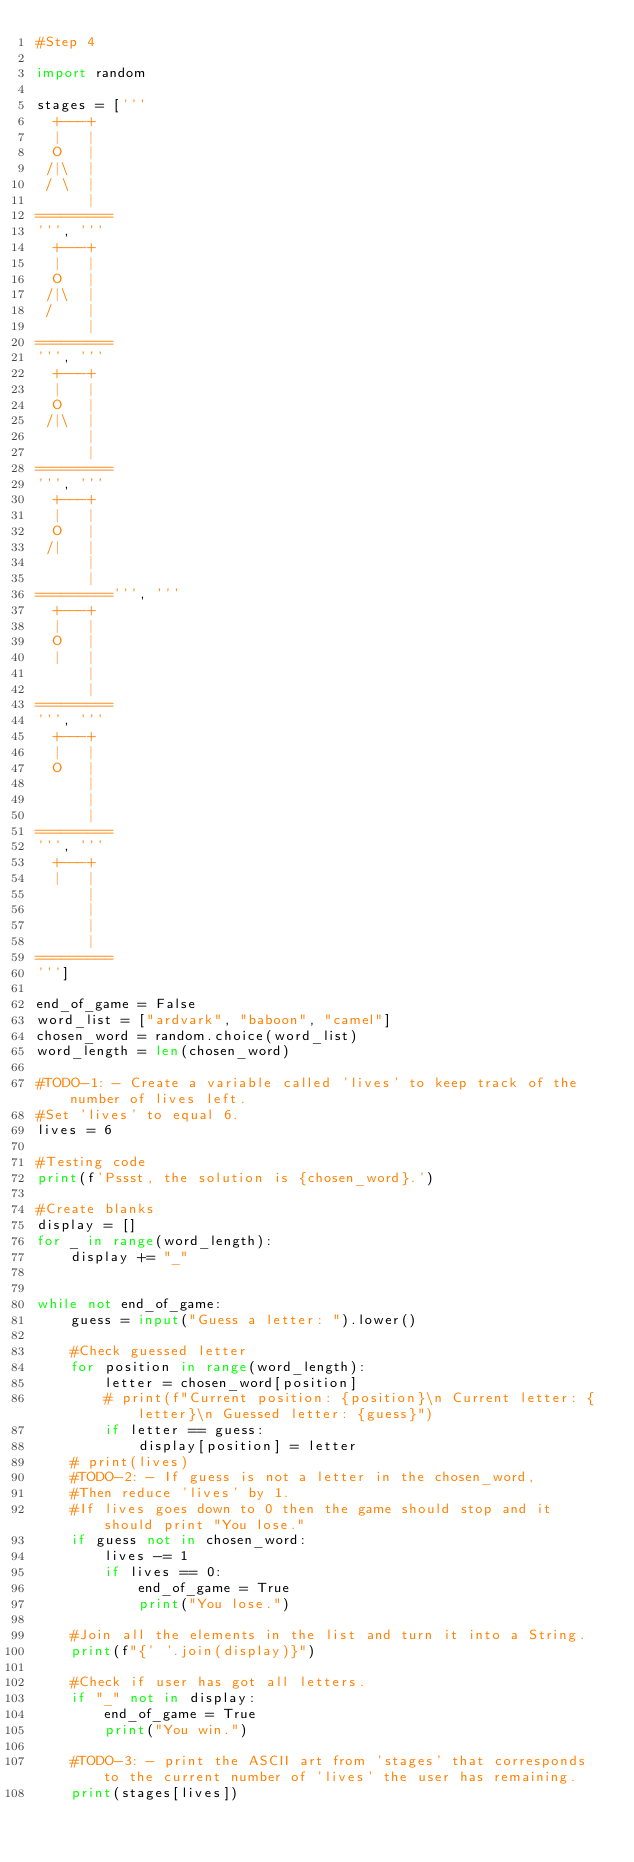Convert code to text. <code><loc_0><loc_0><loc_500><loc_500><_Python_>#Step 4

import random

stages = ['''
  +---+
  |   |
  O   |
 /|\  |
 / \  |
      |
=========
''', '''
  +---+
  |   |
  O   |
 /|\  |
 /    |
      |
=========
''', '''
  +---+
  |   |
  O   |
 /|\  |
      |
      |
=========
''', '''
  +---+
  |   |
  O   |
 /|   |
      |
      |
=========''', '''
  +---+
  |   |
  O   |
  |   |
      |
      |
=========
''', '''
  +---+
  |   |
  O   |
      |
      |
      |
=========
''', '''
  +---+
  |   |
      |
      |
      |
      |
=========
''']

end_of_game = False
word_list = ["ardvark", "baboon", "camel"]
chosen_word = random.choice(word_list)
word_length = len(chosen_word)

#TODO-1: - Create a variable called 'lives' to keep track of the number of lives left. 
#Set 'lives' to equal 6.
lives = 6

#Testing code
print(f'Pssst, the solution is {chosen_word}.')

#Create blanks
display = []
for _ in range(word_length):
    display += "_"


while not end_of_game:
    guess = input("Guess a letter: ").lower()

    #Check guessed letter
    for position in range(word_length):
        letter = chosen_word[position]
        # print(f"Current position: {position}\n Current letter: {letter}\n Guessed letter: {guess}")
        if letter == guess:
            display[position] = letter
    # print(lives)
    #TODO-2: - If guess is not a letter in the chosen_word,
    #Then reduce 'lives' by 1. 
    #If lives goes down to 0 then the game should stop and it should print "You lose."
    if guess not in chosen_word:
        lives -= 1
        if lives == 0:
            end_of_game = True
            print("You lose.")
    
    #Join all the elements in the list and turn it into a String.
    print(f"{' '.join(display)}")

    #Check if user has got all letters.
    if "_" not in display:
        end_of_game = True
        print("You win.")

    #TODO-3: - print the ASCII art from 'stages' that corresponds to the current number of 'lives' the user has remaining.
    print(stages[lives])

</code> 